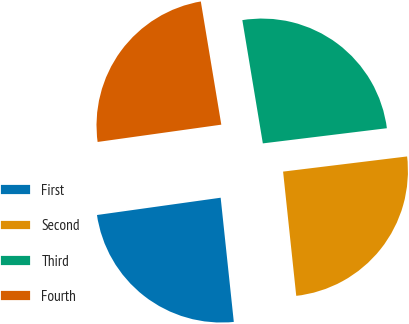Convert chart to OTSL. <chart><loc_0><loc_0><loc_500><loc_500><pie_chart><fcel>First<fcel>Second<fcel>Third<fcel>Fourth<nl><fcel>24.47%<fcel>25.26%<fcel>25.69%<fcel>24.59%<nl></chart> 